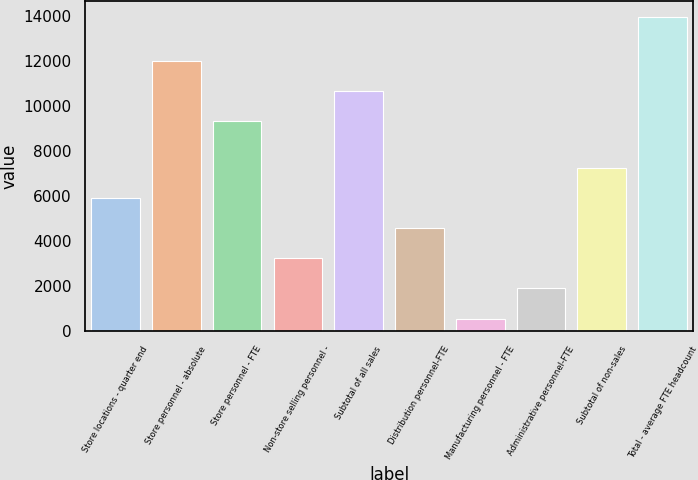Convert chart. <chart><loc_0><loc_0><loc_500><loc_500><bar_chart><fcel>Store locations - quarter end<fcel>Store personnel - absolute<fcel>Store personnel - FTE<fcel>Non-store selling personnel -<fcel>Subtotal of all sales<fcel>Distribution personnel-FTE<fcel>Manufacturing personnel - FTE<fcel>Administrative personnel-FTE<fcel>Subtotal of non-sales<fcel>Total - average FTE headcount<nl><fcel>5927.2<fcel>12028.6<fcel>9350<fcel>3248.6<fcel>10689.3<fcel>4587.9<fcel>570<fcel>1909.3<fcel>7266.5<fcel>13963<nl></chart> 